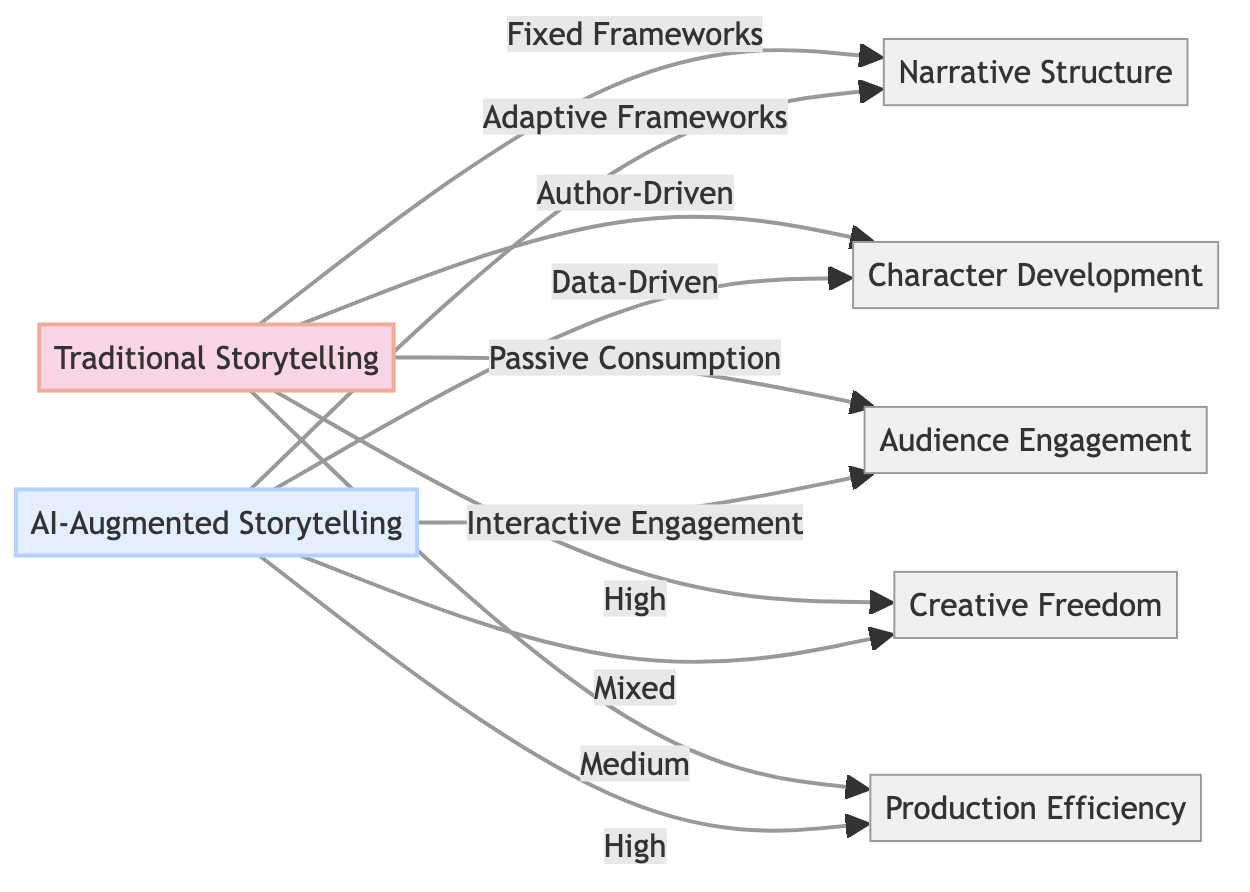What is the relationship between Traditional Storytelling and Narrative Structure? The diagram indicates that Traditional Storytelling has a connection labeled "Fixed Frameworks" to the Narrative Structure node. This shows that Traditional Storytelling adheres to a set narrative format.
Answer: Fixed Frameworks What type of frameworks does AI-Augmented Storytelling use in relation to Narrative Structure? According to the diagram, AI-Augmented Storytelling connects to Narrative Structure through "Adaptive Frameworks," indicating a more flexible approach to storytelling.
Answer: Adaptive Frameworks Which approach employs Data-Driven character development? The diagram clearly outlines that AI-Augmented Storytelling is linked to Character Development by the label "Data-Driven," illustrating how it uses data analytics for character creation.
Answer: AI-Augmented Storytelling How does Audience Engagement differ between traditional and AI-augmented methods? The diagram specifies "Passive Consumption" for Traditional Storytelling and "Interactive Engagement" for AI-Augmented Storytelling, highlighting the difference in audience involvement.
Answer: Passive Consumption vs. Interactive Engagement What is the level of Creative Freedom in Traditional Storytelling? The diagram points to Traditional Storytelling as having "High" Creative Freedom, which means authors have significant liberty in shaping their narratives.
Answer: High What is the stated production efficiency for AI-Augmented Storytelling? The link shows that AI-Augmented Storytelling has a "High" level of Production Efficiency, indicating it is more effective in terms of resources and time.
Answer: High Which storytelling method tends to have Mixed Creative Freedom? The diagram connects the "Mixed" Creative Freedom to AI-Augmented Storytelling, suggesting that there is a balance in creative control.
Answer: AI-Augmented Storytelling How many nodes represent storytelling aspects in the diagram? In the diagram, there are five nodes labeled as aspects: Narrative Structure, Character Development, Audience Engagement, Creative Freedom, and Production Efficiency, totaling five nodes.
Answer: Five What does the relationship between Traditional Storytelling and Audience Engagement indicate? The relationship shows that Traditional Storytelling is characterized by "Passive Consumption," indicating that audiences receive the story without active participation, contrasting with AI methods.
Answer: Passive Consumption What is a unique feature of AI-Augmented Storytelling compared to traditional methods regarding Character Development? The diagram illustrates that AI-Augmented Storytelling's unique aspect in Character Development is being "Data-Driven," which contrasts with the author-driven approach of Traditional Storytelling.
Answer: Data-Driven 